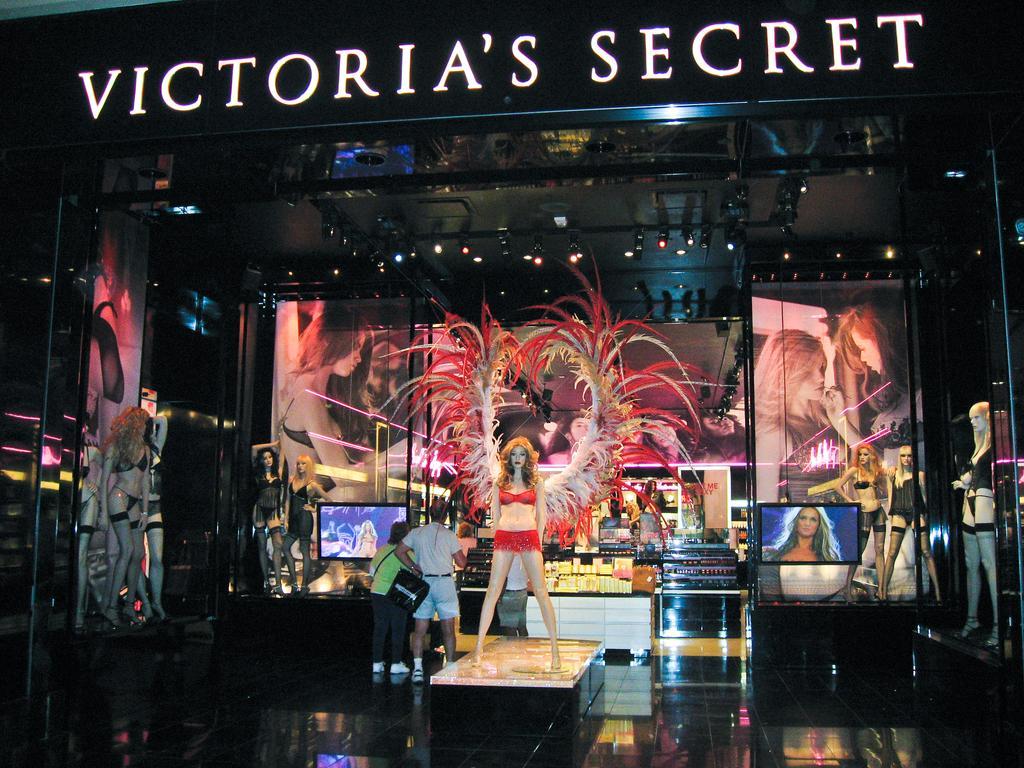Describe this image in one or two sentences. In the center of the image, we can see a lady wearing costume and in the background, there are screens, lights, and some people standing and there are mannequins. 